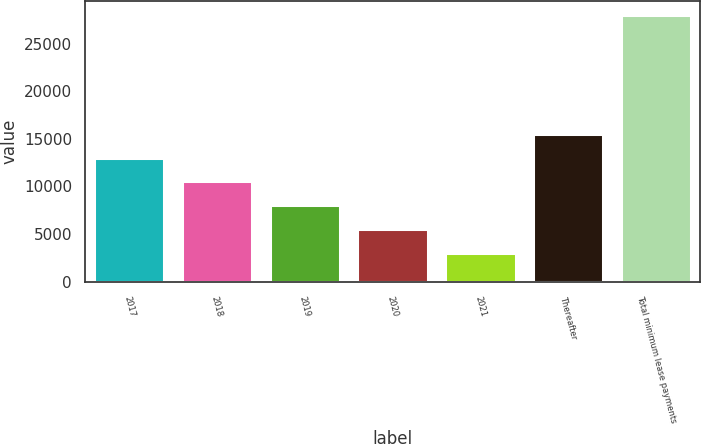Convert chart. <chart><loc_0><loc_0><loc_500><loc_500><bar_chart><fcel>2017<fcel>2018<fcel>2019<fcel>2020<fcel>2021<fcel>Thereafter<fcel>Total minimum lease payments<nl><fcel>13027<fcel>10526<fcel>8025<fcel>5524<fcel>3023<fcel>15528<fcel>28033<nl></chart> 